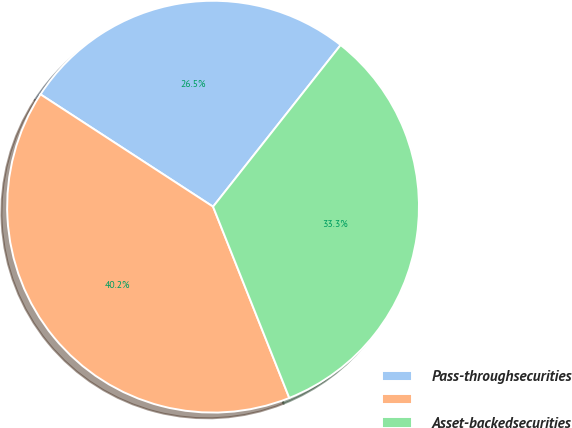Convert chart. <chart><loc_0><loc_0><loc_500><loc_500><pie_chart><fcel>Pass-throughsecurities<fcel>Unnamed: 1<fcel>Asset-backedsecurities<nl><fcel>26.45%<fcel>40.22%<fcel>33.33%<nl></chart> 